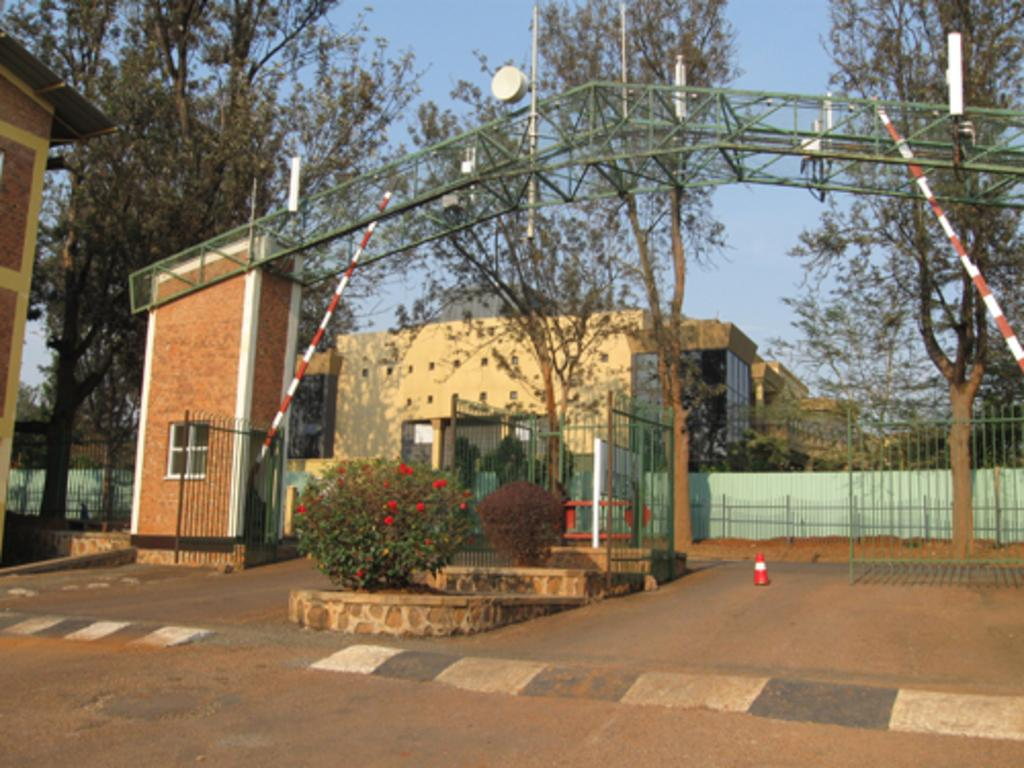What type of structures can be seen in the image? There are buildings in the image. What architectural feature is present in the image? There is a gate in the image. What type of barrier can be seen in the image? There is a fence in the image. What vertical object is present in the image? There is a pole in the image. What type of entrance is depicted in the image? There is an arch in the image. What type of vegetation is present in the image? There are plants, flowers, and trees in the image. What type of pathway is present in the image? There is a road in the image. What part of the natural environment is visible in the image? The sky is visible in the image. Who is the owner of the selection of buildings in the image? There is no information about the ownership of the buildings in the image. What type of decision-making process is depicted in the image? There is no decision-making process or selection being depicted in the image. 